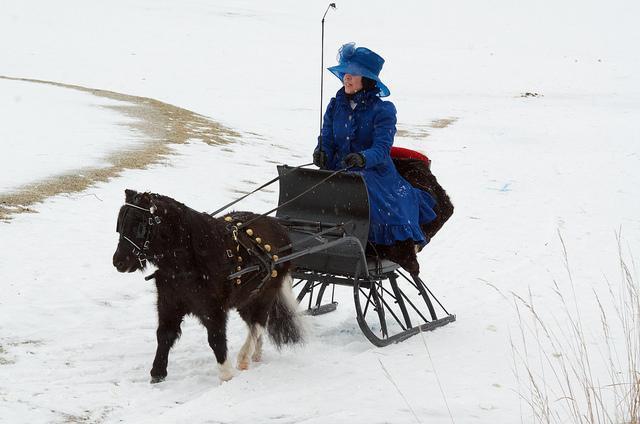How many people are riding on this sled?
Give a very brief answer. 1. How many beds are under the lamp?
Give a very brief answer. 0. 